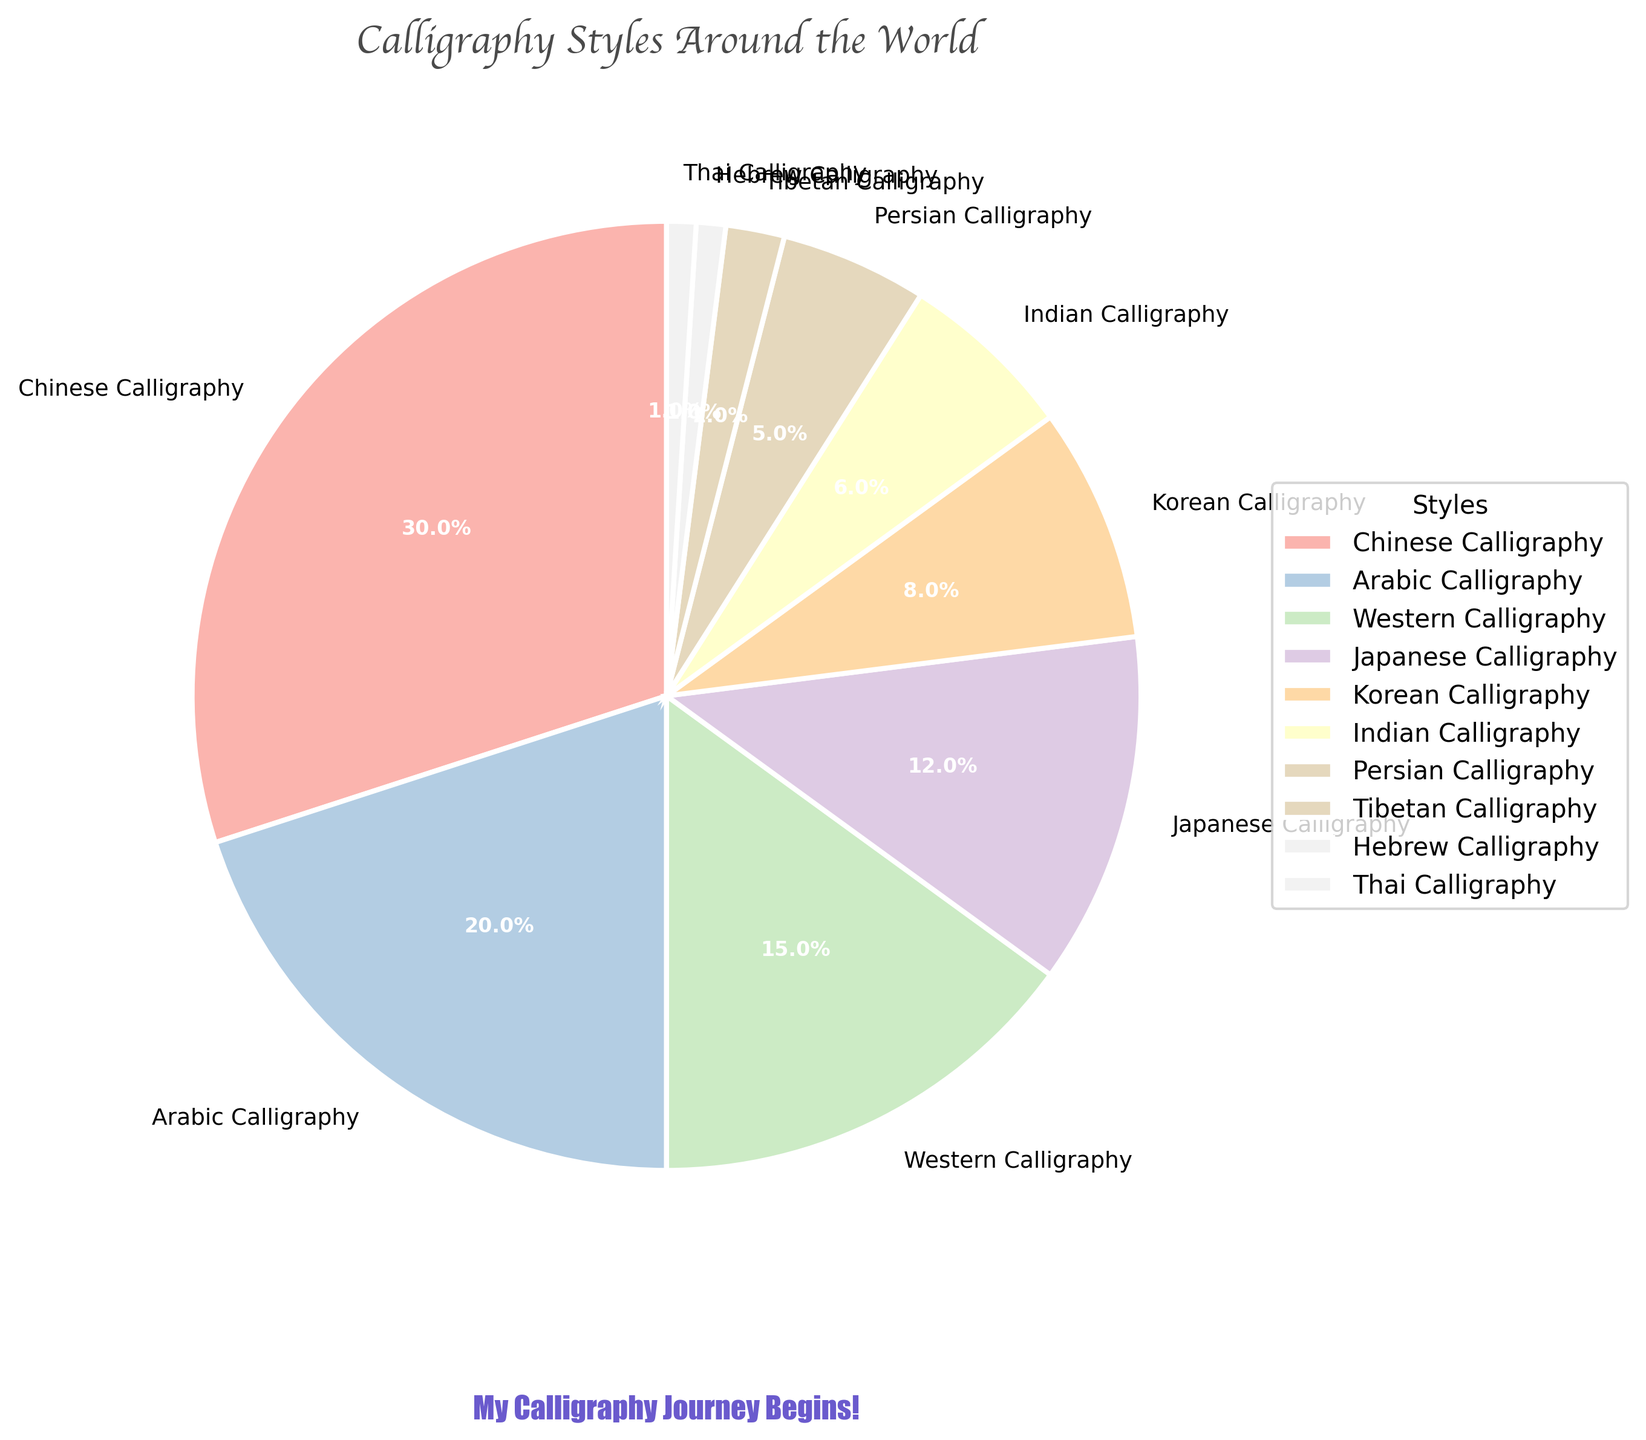What's the largest calligraphy style group shown in the pie chart? The largest section of the pie chart can be identified by its size. "Chinese Calligraphy" occupies the largest portion, indicating it accounts for the highest percentage.
Answer: Chinese Calligraphy What's the combined percentage of Japanese and Korean Calligraphy styles? To find the combined percentage, add the percentages of Japanese Calligraphy (12%) and Korean Calligraphy (8%). The sum is 12% + 8% = 20%.
Answer: 20% Which has a higher percentage: Indian Calligraphy or Persian Calligraphy? Comparing the two segments of the pie chart, "Indian Calligraphy" has 6%, and "Persian Calligraphy" has 5%. 6% is greater than 5%.
Answer: Indian Calligraphy What is the sum of the percentages for Western, Tibetan, and Thai Calligraphy styles? Adding the percentages: Western Calligraphy (15%), Tibetan Calligraphy (2%), and Thai Calligraphy (1%) results in 15% + 2% + 1% = 18%.
Answer: 18% Which styles have a percentage lower than 10% but higher than 5%? By examining the chart, "Indian Calligraphy" is 6% and "Korean Calligraphy" is 8%. These values fit the criteria of being lower than 10% but higher than 5%.
Answer: Indian Calligraphy, Korean Calligraphy How much larger is the percentage of Arabic Calligraphy compared to Hebrew Calligraphy? Subtract the percentage of Hebrew Calligraphy (1%) from Arabic Calligraphy (20%): 20% - 1% = 19%. Arabic Calligraphy is 19% larger than Hebrew Calligraphy.
Answer: 19% What is the visual characteristic of the label text used in the pie chart? The label texts on the pie chart are set to a size that makes them clear and easy to read, specifically at a size of 9.
Answer: Size 9 How much smaller is Tibetan Calligraphy than Indian Calligraphy in percentage terms? Subtract the percentage of Tibetan Calligraphy (2%) from Indian Calligraphy (6%): 6% - 2% = 4%. Tibetan Calligraphy is 4% smaller than Indian Calligraphy.
Answer: 4% 